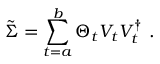<formula> <loc_0><loc_0><loc_500><loc_500>\tilde { \Sigma } = \sum _ { t = a } ^ { b } \Theta _ { t } V _ { t } V _ { t } ^ { \dag } \ .</formula> 